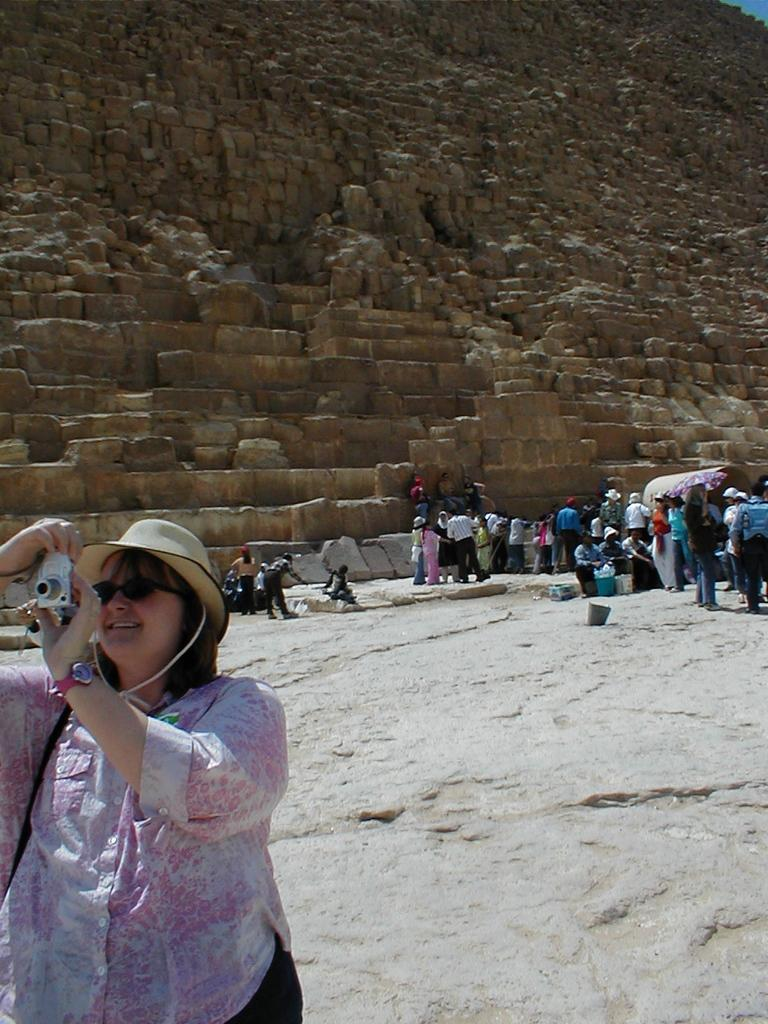What type of structure can be seen in the image? There is a wall in the image. Are there any architectural features present? Yes, there are stairs in the image. Can you describe the people in the image? There is a group of people in the image. What is the position of the woman in the image? The woman is standing on the right side of the image. What is the woman wearing? The woman is wearing a hot pink color dress. What is the woman holding in the image? The woman is holding a camera. What advice does the woman give to the group in the image? There is no indication in the image that the woman is giving advice to the group. 